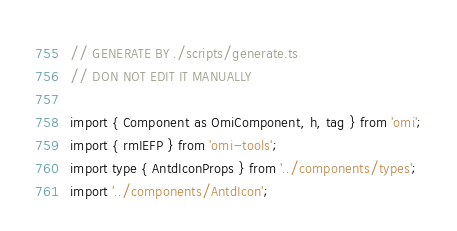Convert code to text. <code><loc_0><loc_0><loc_500><loc_500><_TypeScript_>// GENERATE BY ./scripts/generate.ts
// DON NOT EDIT IT MANUALLY

import { Component as OmiComponent, h, tag } from 'omi';
import { rmIEFP } from 'omi-tools';
import type { AntdIconProps } from '../components/types';
import '../components/AntdIcon';
</code> 